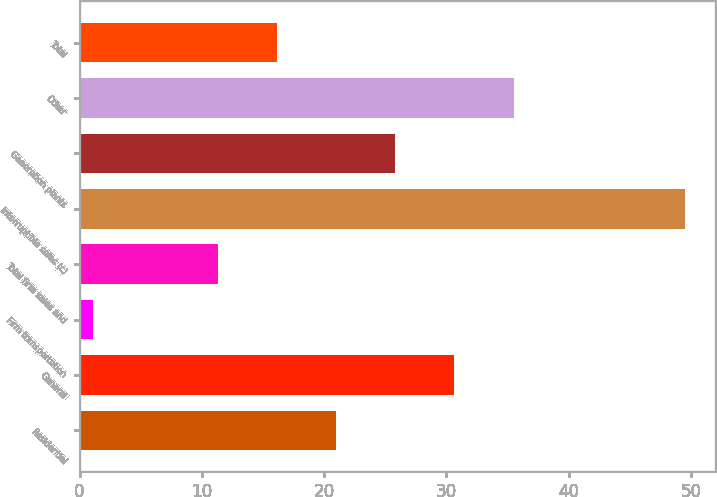<chart> <loc_0><loc_0><loc_500><loc_500><bar_chart><fcel>Residential<fcel>General<fcel>Firm transportation<fcel>Total firm sales and<fcel>Interruptible sales (c)<fcel>Generation plants<fcel>Other<fcel>Total<nl><fcel>20.98<fcel>30.66<fcel>1.1<fcel>11.3<fcel>49.5<fcel>25.82<fcel>35.5<fcel>16.14<nl></chart> 